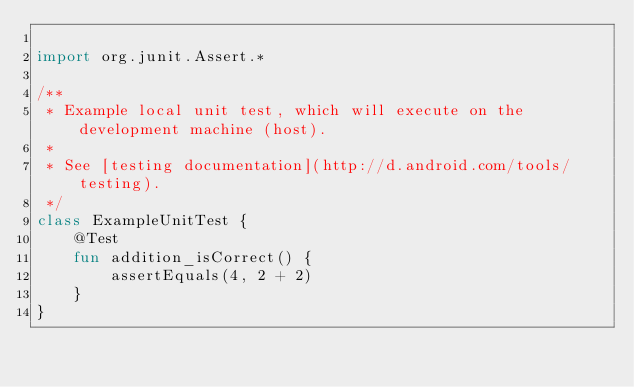Convert code to text. <code><loc_0><loc_0><loc_500><loc_500><_Kotlin_>
import org.junit.Assert.*

/**
 * Example local unit test, which will execute on the development machine (host).
 *
 * See [testing documentation](http://d.android.com/tools/testing).
 */
class ExampleUnitTest {
    @Test
    fun addition_isCorrect() {
        assertEquals(4, 2 + 2)
    }
}</code> 